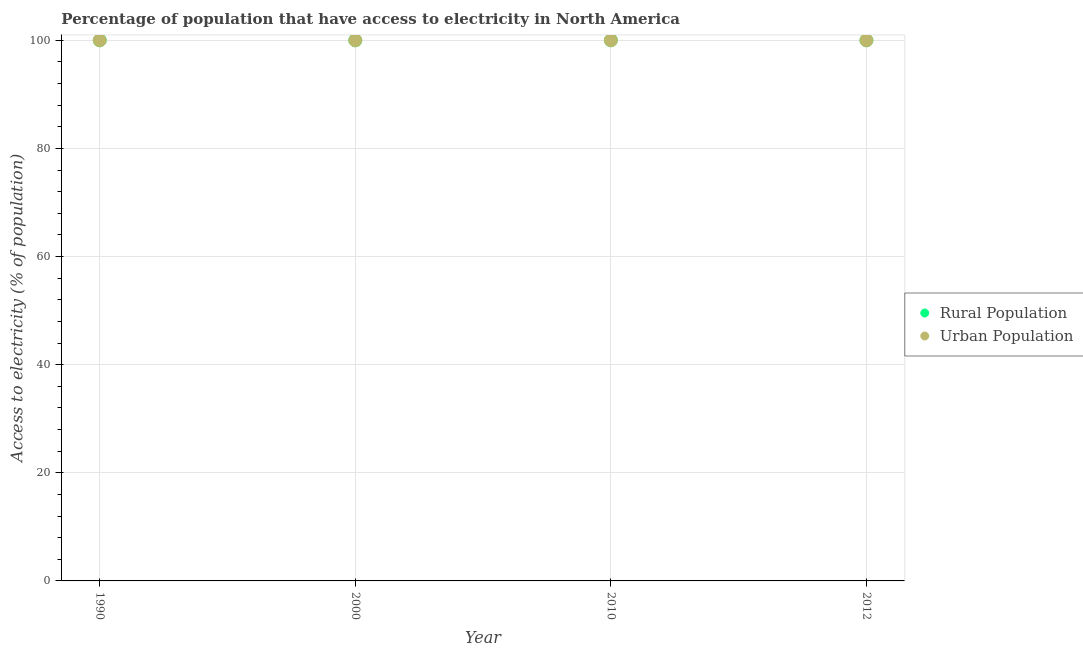How many different coloured dotlines are there?
Your response must be concise. 2. What is the percentage of rural population having access to electricity in 2010?
Your answer should be very brief. 100. Across all years, what is the maximum percentage of urban population having access to electricity?
Your response must be concise. 100. Across all years, what is the minimum percentage of urban population having access to electricity?
Your answer should be very brief. 100. In which year was the percentage of urban population having access to electricity minimum?
Your answer should be compact. 1990. What is the total percentage of rural population having access to electricity in the graph?
Provide a short and direct response. 400. What is the difference between the percentage of rural population having access to electricity in 2010 and that in 2012?
Your answer should be compact. 0. What is the difference between the highest and the lowest percentage of rural population having access to electricity?
Provide a succinct answer. 0. In how many years, is the percentage of urban population having access to electricity greater than the average percentage of urban population having access to electricity taken over all years?
Give a very brief answer. 0. Is the percentage of urban population having access to electricity strictly less than the percentage of rural population having access to electricity over the years?
Your answer should be very brief. No. How many dotlines are there?
Make the answer very short. 2. How many years are there in the graph?
Make the answer very short. 4. Where does the legend appear in the graph?
Provide a succinct answer. Center right. What is the title of the graph?
Your answer should be compact. Percentage of population that have access to electricity in North America. What is the label or title of the Y-axis?
Your response must be concise. Access to electricity (% of population). What is the Access to electricity (% of population) of Rural Population in 2000?
Your answer should be compact. 100. What is the Access to electricity (% of population) in Urban Population in 2000?
Offer a terse response. 100. What is the Access to electricity (% of population) in Rural Population in 2012?
Offer a very short reply. 100. Across all years, what is the maximum Access to electricity (% of population) of Rural Population?
Your response must be concise. 100. Across all years, what is the maximum Access to electricity (% of population) of Urban Population?
Your answer should be compact. 100. What is the total Access to electricity (% of population) of Urban Population in the graph?
Your answer should be compact. 400. What is the difference between the Access to electricity (% of population) of Rural Population in 1990 and that in 2000?
Offer a terse response. 0. What is the difference between the Access to electricity (% of population) in Urban Population in 1990 and that in 2000?
Ensure brevity in your answer.  0. What is the difference between the Access to electricity (% of population) of Rural Population in 1990 and that in 2010?
Give a very brief answer. 0. What is the difference between the Access to electricity (% of population) of Rural Population in 1990 and that in 2012?
Offer a very short reply. 0. What is the difference between the Access to electricity (% of population) of Urban Population in 2000 and that in 2010?
Provide a succinct answer. 0. What is the difference between the Access to electricity (% of population) in Rural Population in 2000 and that in 2012?
Your answer should be very brief. 0. What is the difference between the Access to electricity (% of population) of Rural Population in 2010 and that in 2012?
Your answer should be very brief. 0. What is the difference between the Access to electricity (% of population) in Rural Population in 1990 and the Access to electricity (% of population) in Urban Population in 2000?
Provide a short and direct response. 0. What is the difference between the Access to electricity (% of population) of Rural Population in 1990 and the Access to electricity (% of population) of Urban Population in 2012?
Ensure brevity in your answer.  0. What is the difference between the Access to electricity (% of population) in Rural Population in 2000 and the Access to electricity (% of population) in Urban Population in 2012?
Make the answer very short. 0. What is the average Access to electricity (% of population) in Urban Population per year?
Provide a succinct answer. 100. In the year 2012, what is the difference between the Access to electricity (% of population) in Rural Population and Access to electricity (% of population) in Urban Population?
Provide a succinct answer. 0. What is the ratio of the Access to electricity (% of population) of Urban Population in 1990 to that in 2000?
Your answer should be compact. 1. What is the ratio of the Access to electricity (% of population) of Rural Population in 1990 to that in 2010?
Provide a succinct answer. 1. What is the ratio of the Access to electricity (% of population) in Rural Population in 2000 to that in 2010?
Offer a terse response. 1. What is the ratio of the Access to electricity (% of population) of Urban Population in 2000 to that in 2010?
Your answer should be very brief. 1. What is the ratio of the Access to electricity (% of population) in Urban Population in 2000 to that in 2012?
Offer a very short reply. 1. What is the ratio of the Access to electricity (% of population) in Rural Population in 2010 to that in 2012?
Offer a terse response. 1. What is the difference between the highest and the second highest Access to electricity (% of population) in Urban Population?
Keep it short and to the point. 0. What is the difference between the highest and the lowest Access to electricity (% of population) of Rural Population?
Your response must be concise. 0. What is the difference between the highest and the lowest Access to electricity (% of population) of Urban Population?
Keep it short and to the point. 0. 